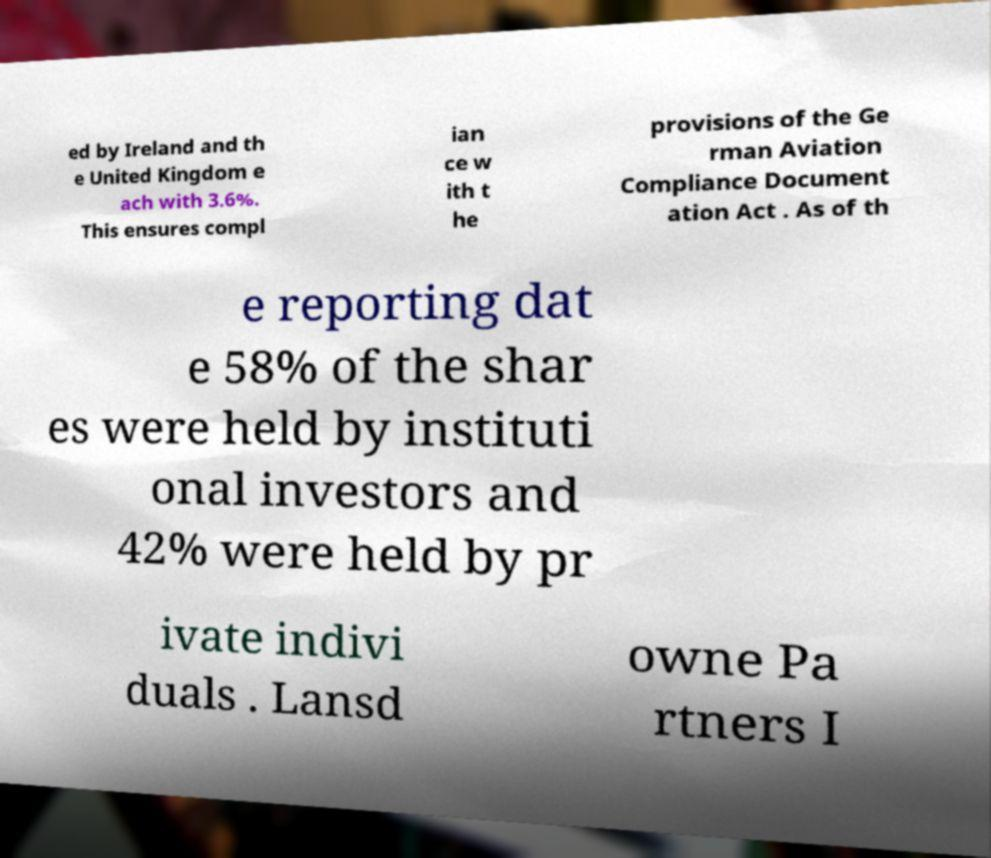What messages or text are displayed in this image? I need them in a readable, typed format. ed by Ireland and th e United Kingdom e ach with 3.6%. This ensures compl ian ce w ith t he provisions of the Ge rman Aviation Compliance Document ation Act . As of th e reporting dat e 58% of the shar es were held by instituti onal investors and 42% were held by pr ivate indivi duals . Lansd owne Pa rtners I 